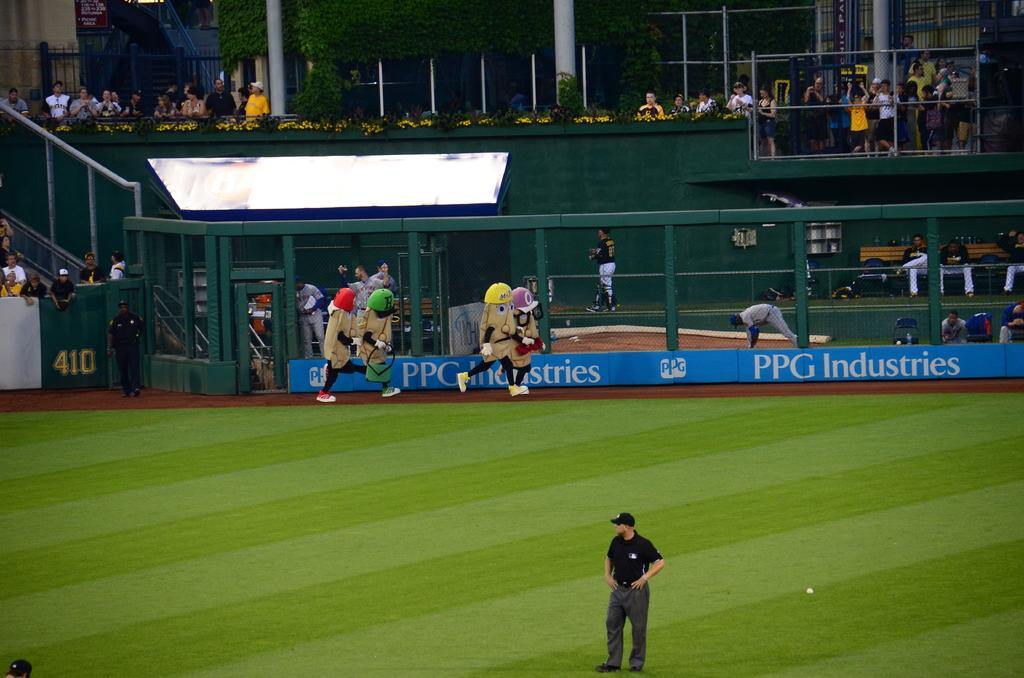<image>
Present a compact description of the photo's key features. A group of mascots run along the dirt track in front of the PPG Industries sign. 